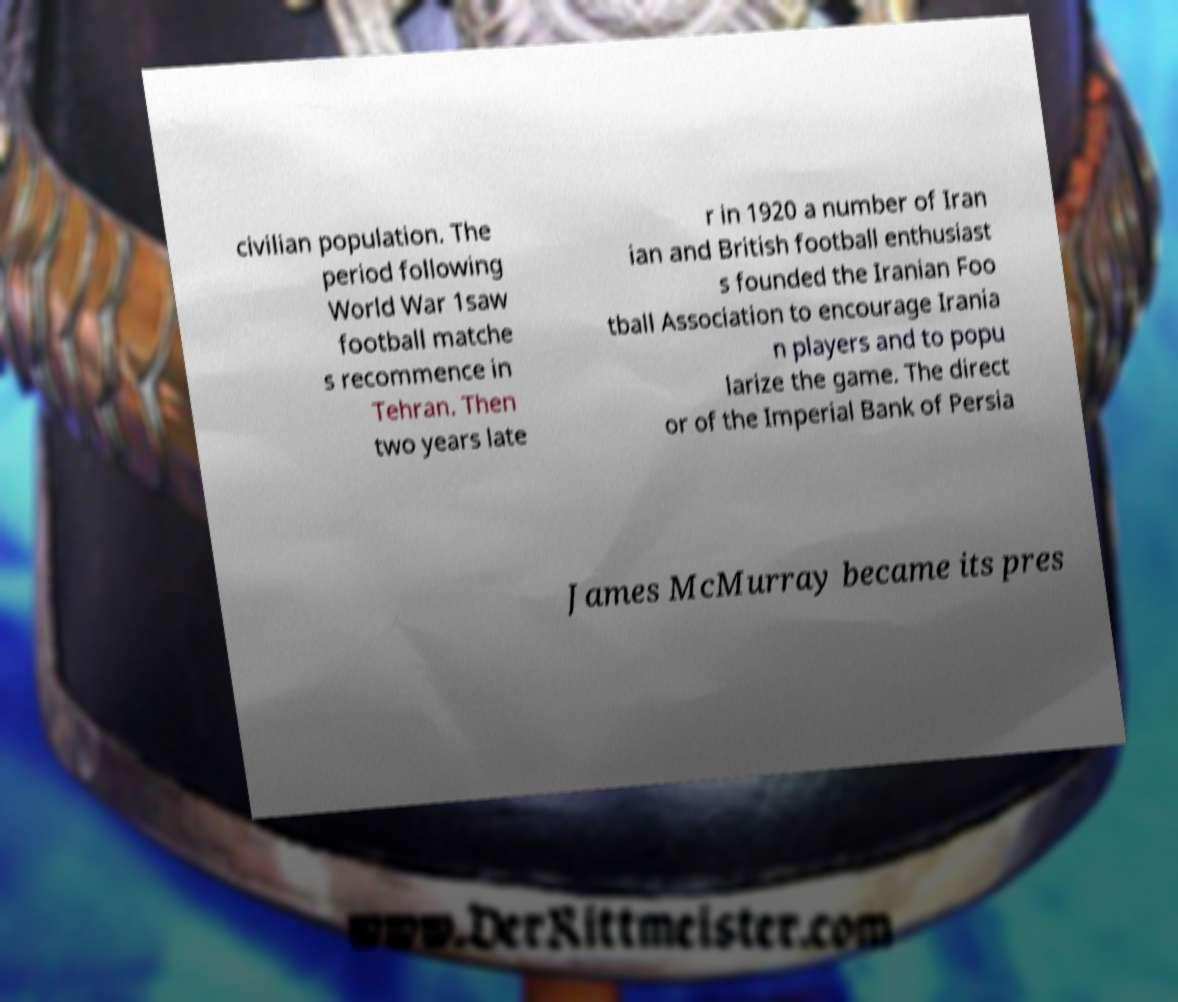Please identify and transcribe the text found in this image. civilian population. The period following World War 1saw football matche s recommence in Tehran. Then two years late r in 1920 a number of Iran ian and British football enthusiast s founded the Iranian Foo tball Association to encourage Irania n players and to popu larize the game. The direct or of the Imperial Bank of Persia James McMurray became its pres 